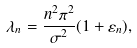Convert formula to latex. <formula><loc_0><loc_0><loc_500><loc_500>\lambda _ { n } = \frac { n ^ { 2 } \pi ^ { 2 } } { \sigma ^ { 2 } } ( 1 + \varepsilon _ { n } ) ,</formula> 